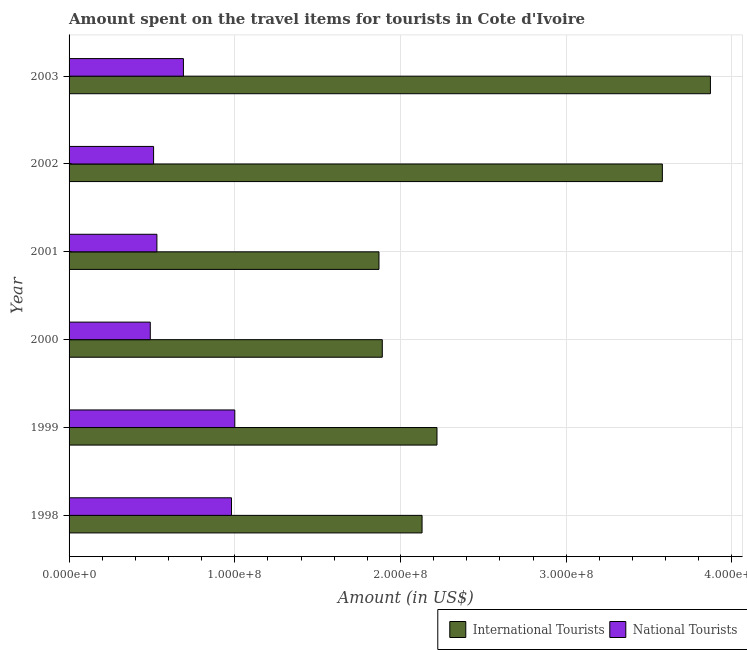Are the number of bars per tick equal to the number of legend labels?
Provide a succinct answer. Yes. How many bars are there on the 5th tick from the top?
Your response must be concise. 2. How many bars are there on the 5th tick from the bottom?
Give a very brief answer. 2. What is the label of the 1st group of bars from the top?
Offer a terse response. 2003. In how many cases, is the number of bars for a given year not equal to the number of legend labels?
Make the answer very short. 0. What is the amount spent on travel items of national tourists in 2000?
Give a very brief answer. 4.90e+07. Across all years, what is the maximum amount spent on travel items of national tourists?
Make the answer very short. 1.00e+08. Across all years, what is the minimum amount spent on travel items of national tourists?
Give a very brief answer. 4.90e+07. What is the total amount spent on travel items of national tourists in the graph?
Your answer should be very brief. 4.20e+08. What is the difference between the amount spent on travel items of international tourists in 1998 and that in 2003?
Provide a succinct answer. -1.74e+08. What is the difference between the amount spent on travel items of international tourists in 2002 and the amount spent on travel items of national tourists in 2000?
Provide a succinct answer. 3.09e+08. What is the average amount spent on travel items of international tourists per year?
Keep it short and to the point. 2.59e+08. In the year 2001, what is the difference between the amount spent on travel items of national tourists and amount spent on travel items of international tourists?
Make the answer very short. -1.34e+08. What is the ratio of the amount spent on travel items of international tourists in 1999 to that in 2000?
Offer a very short reply. 1.18. Is the amount spent on travel items of national tourists in 1998 less than that in 2002?
Offer a very short reply. No. What is the difference between the highest and the second highest amount spent on travel items of national tourists?
Your answer should be very brief. 2.00e+06. What is the difference between the highest and the lowest amount spent on travel items of international tourists?
Offer a very short reply. 2.00e+08. In how many years, is the amount spent on travel items of international tourists greater than the average amount spent on travel items of international tourists taken over all years?
Offer a terse response. 2. What does the 2nd bar from the top in 1999 represents?
Make the answer very short. International Tourists. What does the 1st bar from the bottom in 2003 represents?
Your response must be concise. International Tourists. Are all the bars in the graph horizontal?
Your response must be concise. Yes. What is the difference between two consecutive major ticks on the X-axis?
Provide a short and direct response. 1.00e+08. Are the values on the major ticks of X-axis written in scientific E-notation?
Provide a short and direct response. Yes. Does the graph contain any zero values?
Provide a short and direct response. No. Does the graph contain grids?
Provide a succinct answer. Yes. How many legend labels are there?
Provide a short and direct response. 2. What is the title of the graph?
Offer a very short reply. Amount spent on the travel items for tourists in Cote d'Ivoire. Does "Male labourers" appear as one of the legend labels in the graph?
Offer a very short reply. No. What is the label or title of the X-axis?
Provide a succinct answer. Amount (in US$). What is the label or title of the Y-axis?
Provide a short and direct response. Year. What is the Amount (in US$) in International Tourists in 1998?
Provide a short and direct response. 2.13e+08. What is the Amount (in US$) in National Tourists in 1998?
Offer a terse response. 9.80e+07. What is the Amount (in US$) of International Tourists in 1999?
Keep it short and to the point. 2.22e+08. What is the Amount (in US$) in National Tourists in 1999?
Ensure brevity in your answer.  1.00e+08. What is the Amount (in US$) in International Tourists in 2000?
Ensure brevity in your answer.  1.89e+08. What is the Amount (in US$) of National Tourists in 2000?
Ensure brevity in your answer.  4.90e+07. What is the Amount (in US$) in International Tourists in 2001?
Provide a short and direct response. 1.87e+08. What is the Amount (in US$) in National Tourists in 2001?
Your answer should be compact. 5.30e+07. What is the Amount (in US$) of International Tourists in 2002?
Offer a terse response. 3.58e+08. What is the Amount (in US$) of National Tourists in 2002?
Give a very brief answer. 5.10e+07. What is the Amount (in US$) in International Tourists in 2003?
Your answer should be very brief. 3.87e+08. What is the Amount (in US$) of National Tourists in 2003?
Your answer should be very brief. 6.90e+07. Across all years, what is the maximum Amount (in US$) in International Tourists?
Give a very brief answer. 3.87e+08. Across all years, what is the maximum Amount (in US$) of National Tourists?
Give a very brief answer. 1.00e+08. Across all years, what is the minimum Amount (in US$) in International Tourists?
Provide a succinct answer. 1.87e+08. Across all years, what is the minimum Amount (in US$) of National Tourists?
Offer a very short reply. 4.90e+07. What is the total Amount (in US$) in International Tourists in the graph?
Your answer should be very brief. 1.56e+09. What is the total Amount (in US$) of National Tourists in the graph?
Provide a succinct answer. 4.20e+08. What is the difference between the Amount (in US$) of International Tourists in 1998 and that in 1999?
Keep it short and to the point. -9.00e+06. What is the difference between the Amount (in US$) of National Tourists in 1998 and that in 1999?
Provide a succinct answer. -2.00e+06. What is the difference between the Amount (in US$) in International Tourists in 1998 and that in 2000?
Your response must be concise. 2.40e+07. What is the difference between the Amount (in US$) of National Tourists in 1998 and that in 2000?
Your answer should be compact. 4.90e+07. What is the difference between the Amount (in US$) in International Tourists in 1998 and that in 2001?
Give a very brief answer. 2.60e+07. What is the difference between the Amount (in US$) of National Tourists in 1998 and that in 2001?
Your response must be concise. 4.50e+07. What is the difference between the Amount (in US$) in International Tourists in 1998 and that in 2002?
Offer a very short reply. -1.45e+08. What is the difference between the Amount (in US$) in National Tourists in 1998 and that in 2002?
Keep it short and to the point. 4.70e+07. What is the difference between the Amount (in US$) of International Tourists in 1998 and that in 2003?
Make the answer very short. -1.74e+08. What is the difference between the Amount (in US$) of National Tourists in 1998 and that in 2003?
Offer a terse response. 2.90e+07. What is the difference between the Amount (in US$) in International Tourists in 1999 and that in 2000?
Make the answer very short. 3.30e+07. What is the difference between the Amount (in US$) in National Tourists in 1999 and that in 2000?
Make the answer very short. 5.10e+07. What is the difference between the Amount (in US$) of International Tourists in 1999 and that in 2001?
Provide a succinct answer. 3.50e+07. What is the difference between the Amount (in US$) of National Tourists in 1999 and that in 2001?
Offer a very short reply. 4.70e+07. What is the difference between the Amount (in US$) in International Tourists in 1999 and that in 2002?
Provide a short and direct response. -1.36e+08. What is the difference between the Amount (in US$) of National Tourists in 1999 and that in 2002?
Offer a very short reply. 4.90e+07. What is the difference between the Amount (in US$) of International Tourists in 1999 and that in 2003?
Provide a short and direct response. -1.65e+08. What is the difference between the Amount (in US$) of National Tourists in 1999 and that in 2003?
Give a very brief answer. 3.10e+07. What is the difference between the Amount (in US$) of International Tourists in 2000 and that in 2001?
Your answer should be compact. 2.00e+06. What is the difference between the Amount (in US$) in International Tourists in 2000 and that in 2002?
Make the answer very short. -1.69e+08. What is the difference between the Amount (in US$) of National Tourists in 2000 and that in 2002?
Your answer should be compact. -2.00e+06. What is the difference between the Amount (in US$) of International Tourists in 2000 and that in 2003?
Give a very brief answer. -1.98e+08. What is the difference between the Amount (in US$) in National Tourists in 2000 and that in 2003?
Offer a terse response. -2.00e+07. What is the difference between the Amount (in US$) in International Tourists in 2001 and that in 2002?
Offer a terse response. -1.71e+08. What is the difference between the Amount (in US$) of National Tourists in 2001 and that in 2002?
Offer a very short reply. 2.00e+06. What is the difference between the Amount (in US$) in International Tourists in 2001 and that in 2003?
Ensure brevity in your answer.  -2.00e+08. What is the difference between the Amount (in US$) of National Tourists in 2001 and that in 2003?
Offer a very short reply. -1.60e+07. What is the difference between the Amount (in US$) in International Tourists in 2002 and that in 2003?
Provide a short and direct response. -2.90e+07. What is the difference between the Amount (in US$) in National Tourists in 2002 and that in 2003?
Your answer should be very brief. -1.80e+07. What is the difference between the Amount (in US$) in International Tourists in 1998 and the Amount (in US$) in National Tourists in 1999?
Keep it short and to the point. 1.13e+08. What is the difference between the Amount (in US$) in International Tourists in 1998 and the Amount (in US$) in National Tourists in 2000?
Your answer should be compact. 1.64e+08. What is the difference between the Amount (in US$) in International Tourists in 1998 and the Amount (in US$) in National Tourists in 2001?
Your response must be concise. 1.60e+08. What is the difference between the Amount (in US$) of International Tourists in 1998 and the Amount (in US$) of National Tourists in 2002?
Keep it short and to the point. 1.62e+08. What is the difference between the Amount (in US$) in International Tourists in 1998 and the Amount (in US$) in National Tourists in 2003?
Provide a succinct answer. 1.44e+08. What is the difference between the Amount (in US$) of International Tourists in 1999 and the Amount (in US$) of National Tourists in 2000?
Provide a succinct answer. 1.73e+08. What is the difference between the Amount (in US$) of International Tourists in 1999 and the Amount (in US$) of National Tourists in 2001?
Your answer should be compact. 1.69e+08. What is the difference between the Amount (in US$) of International Tourists in 1999 and the Amount (in US$) of National Tourists in 2002?
Your response must be concise. 1.71e+08. What is the difference between the Amount (in US$) in International Tourists in 1999 and the Amount (in US$) in National Tourists in 2003?
Give a very brief answer. 1.53e+08. What is the difference between the Amount (in US$) of International Tourists in 2000 and the Amount (in US$) of National Tourists in 2001?
Offer a terse response. 1.36e+08. What is the difference between the Amount (in US$) in International Tourists in 2000 and the Amount (in US$) in National Tourists in 2002?
Your response must be concise. 1.38e+08. What is the difference between the Amount (in US$) in International Tourists in 2000 and the Amount (in US$) in National Tourists in 2003?
Offer a very short reply. 1.20e+08. What is the difference between the Amount (in US$) in International Tourists in 2001 and the Amount (in US$) in National Tourists in 2002?
Your answer should be compact. 1.36e+08. What is the difference between the Amount (in US$) of International Tourists in 2001 and the Amount (in US$) of National Tourists in 2003?
Offer a very short reply. 1.18e+08. What is the difference between the Amount (in US$) of International Tourists in 2002 and the Amount (in US$) of National Tourists in 2003?
Make the answer very short. 2.89e+08. What is the average Amount (in US$) in International Tourists per year?
Make the answer very short. 2.59e+08. What is the average Amount (in US$) in National Tourists per year?
Your response must be concise. 7.00e+07. In the year 1998, what is the difference between the Amount (in US$) of International Tourists and Amount (in US$) of National Tourists?
Ensure brevity in your answer.  1.15e+08. In the year 1999, what is the difference between the Amount (in US$) in International Tourists and Amount (in US$) in National Tourists?
Provide a succinct answer. 1.22e+08. In the year 2000, what is the difference between the Amount (in US$) of International Tourists and Amount (in US$) of National Tourists?
Keep it short and to the point. 1.40e+08. In the year 2001, what is the difference between the Amount (in US$) of International Tourists and Amount (in US$) of National Tourists?
Your answer should be compact. 1.34e+08. In the year 2002, what is the difference between the Amount (in US$) in International Tourists and Amount (in US$) in National Tourists?
Your response must be concise. 3.07e+08. In the year 2003, what is the difference between the Amount (in US$) in International Tourists and Amount (in US$) in National Tourists?
Ensure brevity in your answer.  3.18e+08. What is the ratio of the Amount (in US$) in International Tourists in 1998 to that in 1999?
Your response must be concise. 0.96. What is the ratio of the Amount (in US$) in International Tourists in 1998 to that in 2000?
Give a very brief answer. 1.13. What is the ratio of the Amount (in US$) of International Tourists in 1998 to that in 2001?
Your answer should be very brief. 1.14. What is the ratio of the Amount (in US$) in National Tourists in 1998 to that in 2001?
Ensure brevity in your answer.  1.85. What is the ratio of the Amount (in US$) in International Tourists in 1998 to that in 2002?
Your answer should be very brief. 0.59. What is the ratio of the Amount (in US$) of National Tourists in 1998 to that in 2002?
Your answer should be compact. 1.92. What is the ratio of the Amount (in US$) in International Tourists in 1998 to that in 2003?
Provide a short and direct response. 0.55. What is the ratio of the Amount (in US$) in National Tourists in 1998 to that in 2003?
Your answer should be compact. 1.42. What is the ratio of the Amount (in US$) in International Tourists in 1999 to that in 2000?
Keep it short and to the point. 1.17. What is the ratio of the Amount (in US$) of National Tourists in 1999 to that in 2000?
Provide a short and direct response. 2.04. What is the ratio of the Amount (in US$) of International Tourists in 1999 to that in 2001?
Keep it short and to the point. 1.19. What is the ratio of the Amount (in US$) of National Tourists in 1999 to that in 2001?
Your response must be concise. 1.89. What is the ratio of the Amount (in US$) of International Tourists in 1999 to that in 2002?
Give a very brief answer. 0.62. What is the ratio of the Amount (in US$) of National Tourists in 1999 to that in 2002?
Your answer should be very brief. 1.96. What is the ratio of the Amount (in US$) of International Tourists in 1999 to that in 2003?
Your answer should be compact. 0.57. What is the ratio of the Amount (in US$) of National Tourists in 1999 to that in 2003?
Keep it short and to the point. 1.45. What is the ratio of the Amount (in US$) in International Tourists in 2000 to that in 2001?
Make the answer very short. 1.01. What is the ratio of the Amount (in US$) in National Tourists in 2000 to that in 2001?
Keep it short and to the point. 0.92. What is the ratio of the Amount (in US$) in International Tourists in 2000 to that in 2002?
Make the answer very short. 0.53. What is the ratio of the Amount (in US$) in National Tourists in 2000 to that in 2002?
Offer a terse response. 0.96. What is the ratio of the Amount (in US$) in International Tourists in 2000 to that in 2003?
Offer a terse response. 0.49. What is the ratio of the Amount (in US$) in National Tourists in 2000 to that in 2003?
Your answer should be compact. 0.71. What is the ratio of the Amount (in US$) of International Tourists in 2001 to that in 2002?
Keep it short and to the point. 0.52. What is the ratio of the Amount (in US$) of National Tourists in 2001 to that in 2002?
Provide a succinct answer. 1.04. What is the ratio of the Amount (in US$) of International Tourists in 2001 to that in 2003?
Your response must be concise. 0.48. What is the ratio of the Amount (in US$) of National Tourists in 2001 to that in 2003?
Keep it short and to the point. 0.77. What is the ratio of the Amount (in US$) of International Tourists in 2002 to that in 2003?
Keep it short and to the point. 0.93. What is the ratio of the Amount (in US$) in National Tourists in 2002 to that in 2003?
Offer a terse response. 0.74. What is the difference between the highest and the second highest Amount (in US$) in International Tourists?
Your response must be concise. 2.90e+07. What is the difference between the highest and the second highest Amount (in US$) of National Tourists?
Ensure brevity in your answer.  2.00e+06. What is the difference between the highest and the lowest Amount (in US$) of International Tourists?
Offer a very short reply. 2.00e+08. What is the difference between the highest and the lowest Amount (in US$) in National Tourists?
Ensure brevity in your answer.  5.10e+07. 